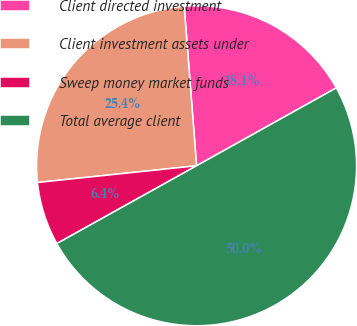Convert chart. <chart><loc_0><loc_0><loc_500><loc_500><pie_chart><fcel>Client directed investment<fcel>Client investment assets under<fcel>Sweep money market funds<fcel>Total average client<nl><fcel>18.14%<fcel>25.43%<fcel>6.42%<fcel>50.0%<nl></chart> 